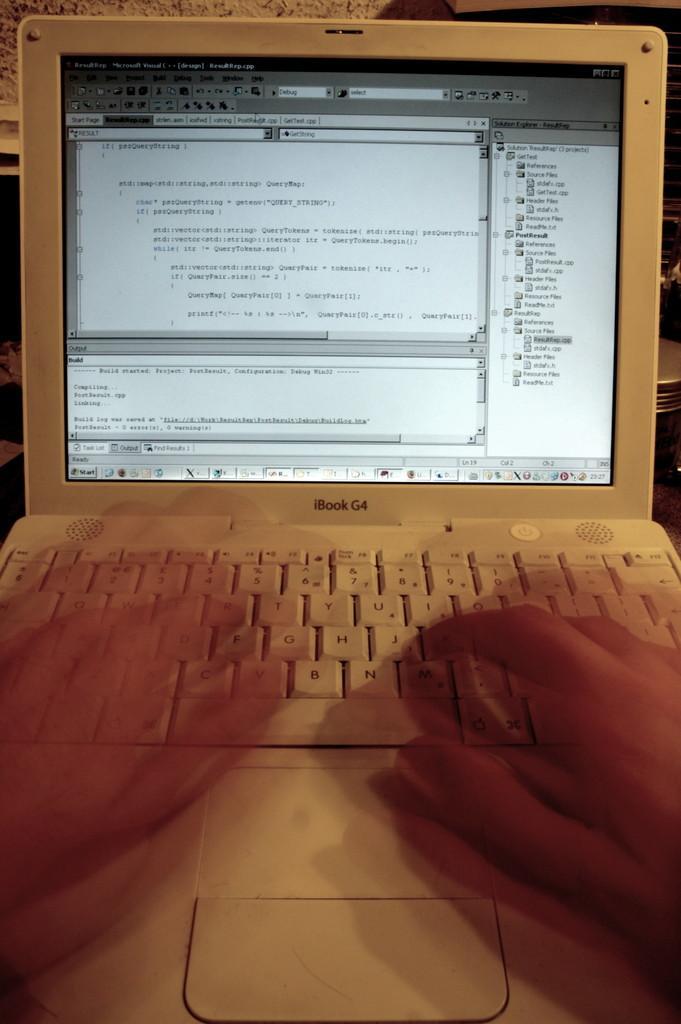Please provide a concise description of this image. In this image there is a person working on a laptop. In the background there are objects. 